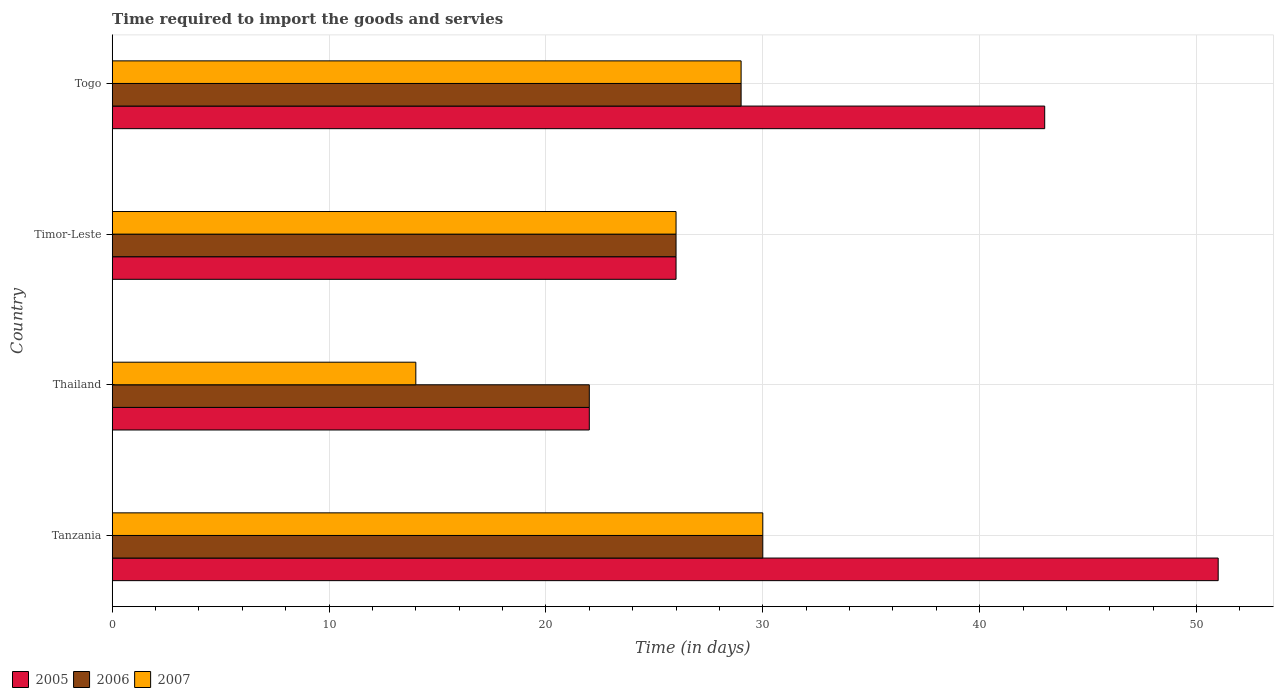How many different coloured bars are there?
Provide a short and direct response. 3. Are the number of bars per tick equal to the number of legend labels?
Offer a very short reply. Yes. How many bars are there on the 2nd tick from the bottom?
Provide a short and direct response. 3. What is the label of the 4th group of bars from the top?
Your answer should be compact. Tanzania. What is the number of days required to import the goods and services in 2006 in Thailand?
Your answer should be compact. 22. Across all countries, what is the maximum number of days required to import the goods and services in 2005?
Offer a very short reply. 51. Across all countries, what is the minimum number of days required to import the goods and services in 2007?
Your answer should be very brief. 14. In which country was the number of days required to import the goods and services in 2007 maximum?
Ensure brevity in your answer.  Tanzania. In which country was the number of days required to import the goods and services in 2007 minimum?
Keep it short and to the point. Thailand. What is the difference between the number of days required to import the goods and services in 2006 in Thailand and the number of days required to import the goods and services in 2007 in Togo?
Ensure brevity in your answer.  -7. What is the average number of days required to import the goods and services in 2005 per country?
Your answer should be very brief. 35.5. What is the difference between the number of days required to import the goods and services in 2005 and number of days required to import the goods and services in 2006 in Thailand?
Make the answer very short. 0. What is the ratio of the number of days required to import the goods and services in 2006 in Thailand to that in Togo?
Provide a succinct answer. 0.76. Is the number of days required to import the goods and services in 2007 in Tanzania less than that in Togo?
Keep it short and to the point. No. What does the 3rd bar from the top in Tanzania represents?
Offer a very short reply. 2005. What does the 1st bar from the bottom in Thailand represents?
Give a very brief answer. 2005. Is it the case that in every country, the sum of the number of days required to import the goods and services in 2006 and number of days required to import the goods and services in 2007 is greater than the number of days required to import the goods and services in 2005?
Make the answer very short. Yes. How many bars are there?
Give a very brief answer. 12. What is the difference between two consecutive major ticks on the X-axis?
Give a very brief answer. 10. Does the graph contain any zero values?
Your response must be concise. No. Does the graph contain grids?
Offer a terse response. Yes. How are the legend labels stacked?
Keep it short and to the point. Horizontal. What is the title of the graph?
Your answer should be very brief. Time required to import the goods and servies. Does "1978" appear as one of the legend labels in the graph?
Provide a succinct answer. No. What is the label or title of the X-axis?
Your response must be concise. Time (in days). What is the label or title of the Y-axis?
Provide a short and direct response. Country. What is the Time (in days) in 2005 in Tanzania?
Offer a very short reply. 51. What is the Time (in days) of 2006 in Tanzania?
Keep it short and to the point. 30. What is the Time (in days) of 2007 in Tanzania?
Your response must be concise. 30. What is the Time (in days) in 2005 in Timor-Leste?
Keep it short and to the point. 26. What is the Time (in days) of 2006 in Timor-Leste?
Offer a terse response. 26. What is the Time (in days) of 2007 in Timor-Leste?
Provide a succinct answer. 26. What is the Time (in days) of 2005 in Togo?
Give a very brief answer. 43. Across all countries, what is the maximum Time (in days) of 2007?
Keep it short and to the point. 30. Across all countries, what is the minimum Time (in days) in 2005?
Give a very brief answer. 22. What is the total Time (in days) in 2005 in the graph?
Make the answer very short. 142. What is the total Time (in days) in 2006 in the graph?
Provide a short and direct response. 107. What is the total Time (in days) of 2007 in the graph?
Your answer should be very brief. 99. What is the difference between the Time (in days) in 2005 in Tanzania and that in Thailand?
Your answer should be compact. 29. What is the difference between the Time (in days) of 2005 in Tanzania and that in Timor-Leste?
Your response must be concise. 25. What is the difference between the Time (in days) in 2006 in Tanzania and that in Togo?
Your answer should be compact. 1. What is the difference between the Time (in days) of 2005 in Thailand and that in Timor-Leste?
Offer a terse response. -4. What is the difference between the Time (in days) in 2006 in Thailand and that in Timor-Leste?
Ensure brevity in your answer.  -4. What is the difference between the Time (in days) of 2006 in Thailand and that in Togo?
Your answer should be very brief. -7. What is the difference between the Time (in days) of 2007 in Thailand and that in Togo?
Your answer should be compact. -15. What is the difference between the Time (in days) in 2006 in Timor-Leste and that in Togo?
Give a very brief answer. -3. What is the difference between the Time (in days) in 2005 in Tanzania and the Time (in days) in 2006 in Thailand?
Give a very brief answer. 29. What is the difference between the Time (in days) in 2005 in Tanzania and the Time (in days) in 2007 in Thailand?
Your response must be concise. 37. What is the difference between the Time (in days) in 2005 in Tanzania and the Time (in days) in 2007 in Timor-Leste?
Your answer should be very brief. 25. What is the difference between the Time (in days) in 2006 in Tanzania and the Time (in days) in 2007 in Timor-Leste?
Provide a short and direct response. 4. What is the difference between the Time (in days) of 2005 in Tanzania and the Time (in days) of 2006 in Togo?
Provide a short and direct response. 22. What is the difference between the Time (in days) in 2005 in Tanzania and the Time (in days) in 2007 in Togo?
Provide a short and direct response. 22. What is the difference between the Time (in days) in 2005 in Thailand and the Time (in days) in 2006 in Timor-Leste?
Your answer should be compact. -4. What is the average Time (in days) in 2005 per country?
Offer a very short reply. 35.5. What is the average Time (in days) of 2006 per country?
Offer a terse response. 26.75. What is the average Time (in days) in 2007 per country?
Offer a very short reply. 24.75. What is the difference between the Time (in days) in 2005 and Time (in days) in 2006 in Tanzania?
Provide a short and direct response. 21. What is the difference between the Time (in days) of 2005 and Time (in days) of 2007 in Tanzania?
Make the answer very short. 21. What is the difference between the Time (in days) of 2005 and Time (in days) of 2007 in Thailand?
Provide a succinct answer. 8. What is the difference between the Time (in days) in 2005 and Time (in days) in 2006 in Timor-Leste?
Your response must be concise. 0. What is the difference between the Time (in days) in 2006 and Time (in days) in 2007 in Togo?
Offer a very short reply. 0. What is the ratio of the Time (in days) of 2005 in Tanzania to that in Thailand?
Your answer should be very brief. 2.32. What is the ratio of the Time (in days) in 2006 in Tanzania to that in Thailand?
Provide a short and direct response. 1.36. What is the ratio of the Time (in days) of 2007 in Tanzania to that in Thailand?
Your answer should be very brief. 2.14. What is the ratio of the Time (in days) in 2005 in Tanzania to that in Timor-Leste?
Provide a succinct answer. 1.96. What is the ratio of the Time (in days) of 2006 in Tanzania to that in Timor-Leste?
Keep it short and to the point. 1.15. What is the ratio of the Time (in days) in 2007 in Tanzania to that in Timor-Leste?
Your answer should be very brief. 1.15. What is the ratio of the Time (in days) in 2005 in Tanzania to that in Togo?
Your response must be concise. 1.19. What is the ratio of the Time (in days) of 2006 in Tanzania to that in Togo?
Your answer should be very brief. 1.03. What is the ratio of the Time (in days) of 2007 in Tanzania to that in Togo?
Make the answer very short. 1.03. What is the ratio of the Time (in days) of 2005 in Thailand to that in Timor-Leste?
Offer a terse response. 0.85. What is the ratio of the Time (in days) in 2006 in Thailand to that in Timor-Leste?
Your response must be concise. 0.85. What is the ratio of the Time (in days) in 2007 in Thailand to that in Timor-Leste?
Ensure brevity in your answer.  0.54. What is the ratio of the Time (in days) of 2005 in Thailand to that in Togo?
Keep it short and to the point. 0.51. What is the ratio of the Time (in days) in 2006 in Thailand to that in Togo?
Keep it short and to the point. 0.76. What is the ratio of the Time (in days) of 2007 in Thailand to that in Togo?
Make the answer very short. 0.48. What is the ratio of the Time (in days) in 2005 in Timor-Leste to that in Togo?
Your answer should be compact. 0.6. What is the ratio of the Time (in days) in 2006 in Timor-Leste to that in Togo?
Provide a short and direct response. 0.9. What is the ratio of the Time (in days) of 2007 in Timor-Leste to that in Togo?
Ensure brevity in your answer.  0.9. What is the difference between the highest and the second highest Time (in days) in 2005?
Keep it short and to the point. 8. What is the difference between the highest and the second highest Time (in days) of 2006?
Provide a succinct answer. 1. What is the difference between the highest and the lowest Time (in days) in 2006?
Provide a short and direct response. 8. 